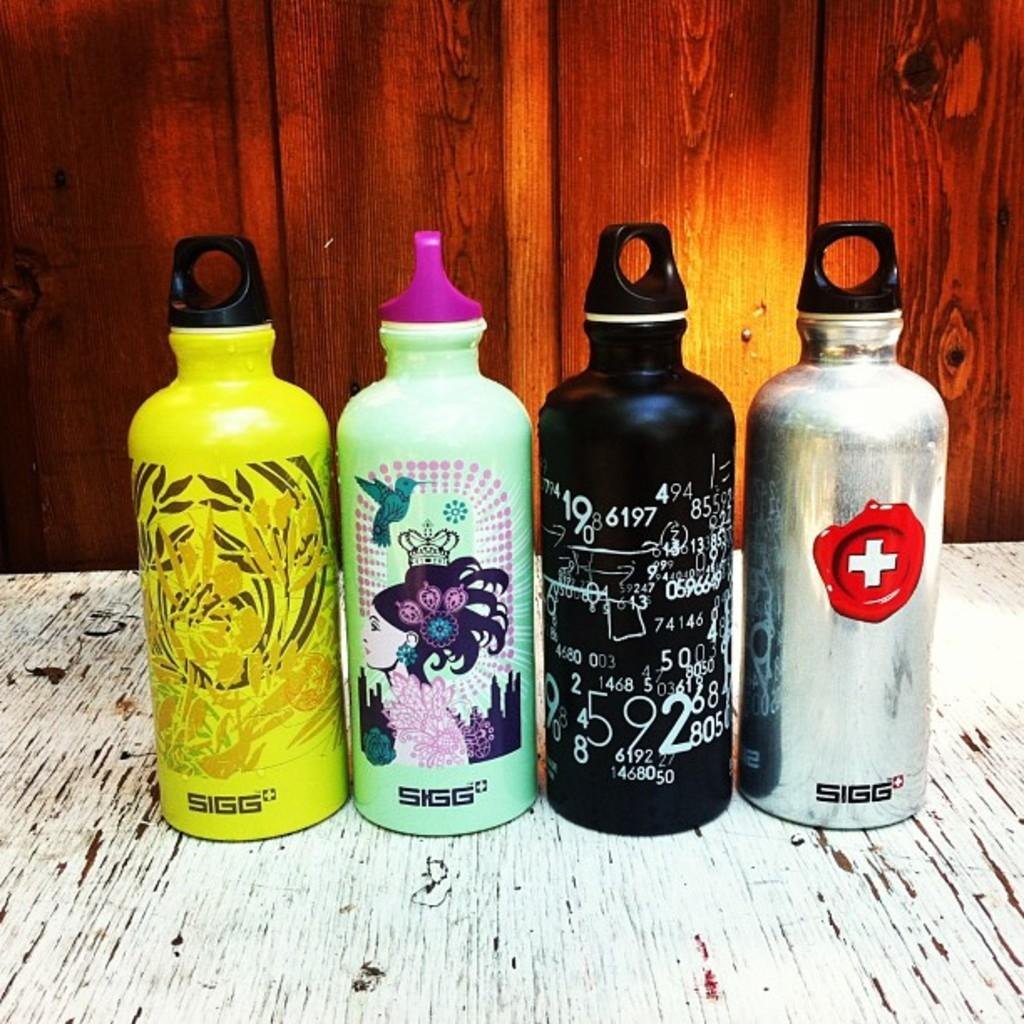<image>
Describe the image concisely. Multiple colorful water bottles by SIGG are displayed on a table. 